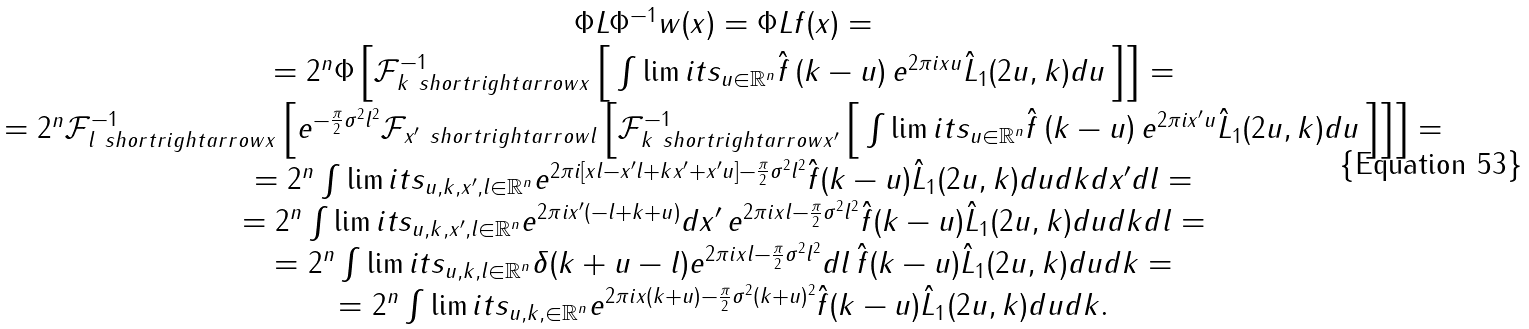Convert formula to latex. <formula><loc_0><loc_0><loc_500><loc_500>\begin{array} { c } \Phi L \Phi ^ { - 1 } w ( x ) = \Phi L f ( x ) = \\ = 2 ^ { n } \Phi \left [ { \mathcal { F } ^ { - 1 } _ { k \ s h o r t r i g h t a r r o w x } \left [ { \, \int \lim i t s _ { u \in \mathbb { R } ^ { n } } { \hat { f } \left ( { k - u } \right ) e ^ { 2 \pi i x u } \hat { L } _ { 1 } ( 2 u , k ) d u } \, } \right ] } \right ] = \\ = 2 ^ { n } \mathcal { F } _ { l \ s h o r t r i g h t a r r o w x } ^ { - 1 } \left [ { e ^ { - \frac { \pi } { 2 } \sigma ^ { 2 } l ^ { 2 } } \mathcal { F } _ { x ^ { \prime } \ s h o r t r i g h t a r r o w l } \left [ { \mathcal { F } ^ { - 1 } _ { k \ s h o r t r i g h t a r r o w x ^ { \prime } } \left [ { \, \int \lim i t s _ { u \in \mathbb { R } ^ { n } } { \hat { f } \left ( { k - u } \right ) e ^ { 2 \pi i x ^ { \prime } u } \hat { L } _ { 1 } ( 2 u , k ) d u } \, } \right ] } \right ] } \right ] = \\ = 2 ^ { n } \int \lim i t s _ { u , k , x ^ { \prime } , l \in \mathbb { R } ^ { n } } { e ^ { 2 \pi i \left [ { x l - x ^ { \prime } l + k x ^ { \prime } + x ^ { \prime } u } \right ] - \frac { \pi } { 2 } \sigma ^ { 2 } l ^ { 2 } } \hat { f } ( k - u ) \hat { L } _ { 1 } ( 2 u , k ) d u d k d x ^ { \prime } d l } = \\ = 2 ^ { n } \int \lim i t s _ { u , k , x ^ { \prime } , l \in \mathbb { R } ^ { n } } { e ^ { 2 \pi i x ^ { \prime } \left ( { - l + k + u } \right ) } d x ^ { \prime } \, e ^ { 2 \pi i x l - \frac { \pi } { 2 } \sigma ^ { 2 } l ^ { 2 } } \hat { f } ( k - u ) \hat { L } _ { 1 } ( 2 u , k ) d u d k d l } = \\ = 2 ^ { n } \int \lim i t s _ { u , k , l \in \mathbb { R } ^ { n } } { \delta ( k + u - l ) e ^ { 2 \pi i x l - \frac { \pi } { 2 } \sigma ^ { 2 } l ^ { 2 } } d l \, \hat { f } ( k - u ) \hat { L } _ { 1 } ( 2 u , k ) d u d k } = \\ = 2 ^ { n } \int \lim i t s _ { u , k , \in \mathbb { R } ^ { n } } { e ^ { 2 \pi i x ( k + u ) - \frac { \pi } { 2 } \sigma ^ { 2 } ( k + u ) ^ { 2 } } \hat { f } ( k - u ) \hat { L } _ { 1 } ( 2 u , k ) d u d k } . \end{array}</formula> 